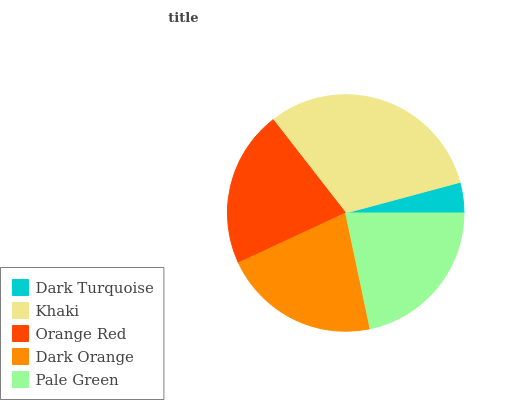Is Dark Turquoise the minimum?
Answer yes or no. Yes. Is Khaki the maximum?
Answer yes or no. Yes. Is Orange Red the minimum?
Answer yes or no. No. Is Orange Red the maximum?
Answer yes or no. No. Is Khaki greater than Orange Red?
Answer yes or no. Yes. Is Orange Red less than Khaki?
Answer yes or no. Yes. Is Orange Red greater than Khaki?
Answer yes or no. No. Is Khaki less than Orange Red?
Answer yes or no. No. Is Orange Red the high median?
Answer yes or no. Yes. Is Orange Red the low median?
Answer yes or no. Yes. Is Dark Orange the high median?
Answer yes or no. No. Is Pale Green the low median?
Answer yes or no. No. 